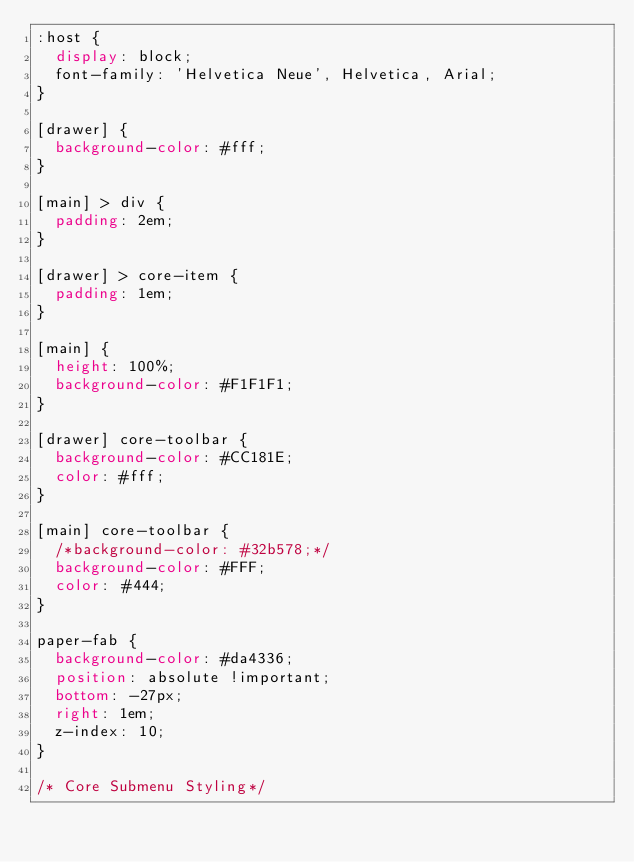<code> <loc_0><loc_0><loc_500><loc_500><_CSS_>:host {
  display: block;
  font-family: 'Helvetica Neue', Helvetica, Arial;
}

[drawer] {
  background-color: #fff;
}

[main] > div {
  padding: 2em;
}

[drawer] > core-item {
  padding: 1em;
}

[main] {
  height: 100%;
  background-color: #F1F1F1;
}

[drawer] core-toolbar {
  background-color: #CC181E;
  color: #fff;
}

[main] core-toolbar {
  /*background-color: #32b578;*/
  background-color: #FFF;
  color: #444;
}

paper-fab {
  background-color: #da4336;
  position: absolute !important;
  bottom: -27px;
  right: 1em;
  z-index: 10;
}

/* Core Submenu Styling*/</code> 